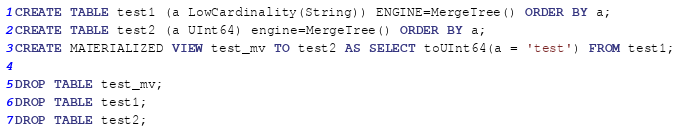<code> <loc_0><loc_0><loc_500><loc_500><_SQL_>CREATE TABLE test1 (a LowCardinality(String)) ENGINE=MergeTree() ORDER BY a;
CREATE TABLE test2 (a UInt64) engine=MergeTree() ORDER BY a;
CREATE MATERIALIZED VIEW test_mv TO test2 AS SELECT toUInt64(a = 'test') FROM test1;

DROP TABLE test_mv;
DROP TABLE test1;
DROP TABLE test2;
</code> 